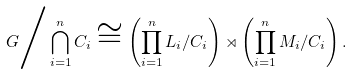Convert formula to latex. <formula><loc_0><loc_0><loc_500><loc_500>G \Big / \bigcap _ { i = 1 } ^ { n } { C _ { i } } \cong \left ( \prod _ { i = 1 } ^ { n } { L _ { i } / C _ { i } } \right ) \rtimes \left ( \prod _ { i = 1 } ^ { n } { M _ { i } / C _ { i } } \right ) .</formula> 